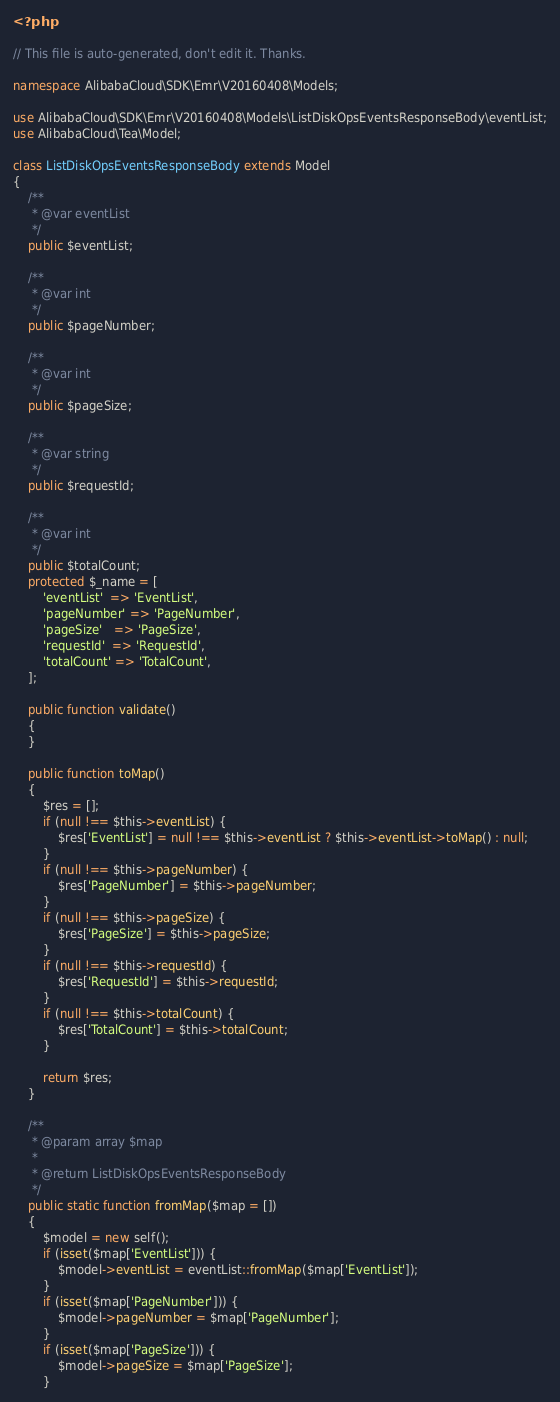Convert code to text. <code><loc_0><loc_0><loc_500><loc_500><_PHP_><?php

// This file is auto-generated, don't edit it. Thanks.

namespace AlibabaCloud\SDK\Emr\V20160408\Models;

use AlibabaCloud\SDK\Emr\V20160408\Models\ListDiskOpsEventsResponseBody\eventList;
use AlibabaCloud\Tea\Model;

class ListDiskOpsEventsResponseBody extends Model
{
    /**
     * @var eventList
     */
    public $eventList;

    /**
     * @var int
     */
    public $pageNumber;

    /**
     * @var int
     */
    public $pageSize;

    /**
     * @var string
     */
    public $requestId;

    /**
     * @var int
     */
    public $totalCount;
    protected $_name = [
        'eventList'  => 'EventList',
        'pageNumber' => 'PageNumber',
        'pageSize'   => 'PageSize',
        'requestId'  => 'RequestId',
        'totalCount' => 'TotalCount',
    ];

    public function validate()
    {
    }

    public function toMap()
    {
        $res = [];
        if (null !== $this->eventList) {
            $res['EventList'] = null !== $this->eventList ? $this->eventList->toMap() : null;
        }
        if (null !== $this->pageNumber) {
            $res['PageNumber'] = $this->pageNumber;
        }
        if (null !== $this->pageSize) {
            $res['PageSize'] = $this->pageSize;
        }
        if (null !== $this->requestId) {
            $res['RequestId'] = $this->requestId;
        }
        if (null !== $this->totalCount) {
            $res['TotalCount'] = $this->totalCount;
        }

        return $res;
    }

    /**
     * @param array $map
     *
     * @return ListDiskOpsEventsResponseBody
     */
    public static function fromMap($map = [])
    {
        $model = new self();
        if (isset($map['EventList'])) {
            $model->eventList = eventList::fromMap($map['EventList']);
        }
        if (isset($map['PageNumber'])) {
            $model->pageNumber = $map['PageNumber'];
        }
        if (isset($map['PageSize'])) {
            $model->pageSize = $map['PageSize'];
        }</code> 